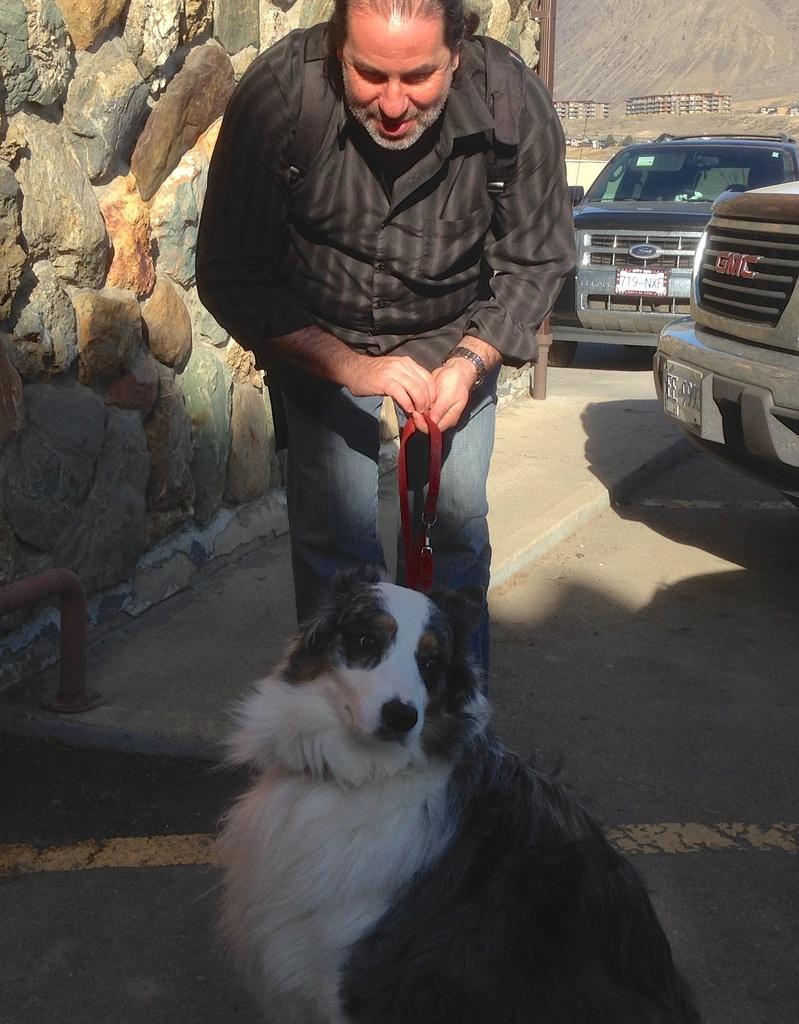Can you describe this image briefly? In the image we can see there is a man who is standing and holding dog and his belt. 